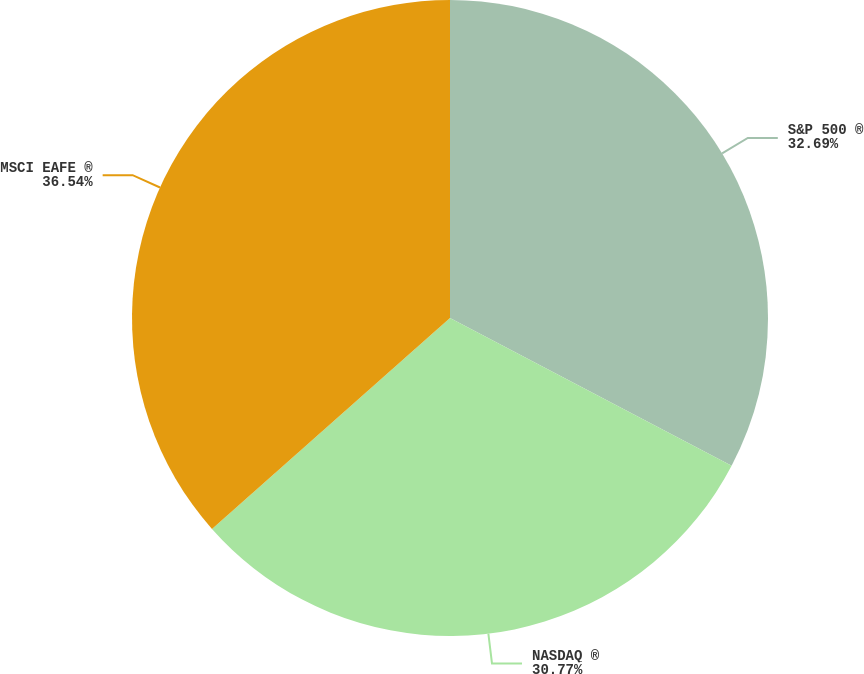Convert chart to OTSL. <chart><loc_0><loc_0><loc_500><loc_500><pie_chart><fcel>S&P 500 ®<fcel>NASDAQ ®<fcel>MSCI EAFE ®<nl><fcel>32.69%<fcel>30.77%<fcel>36.54%<nl></chart> 